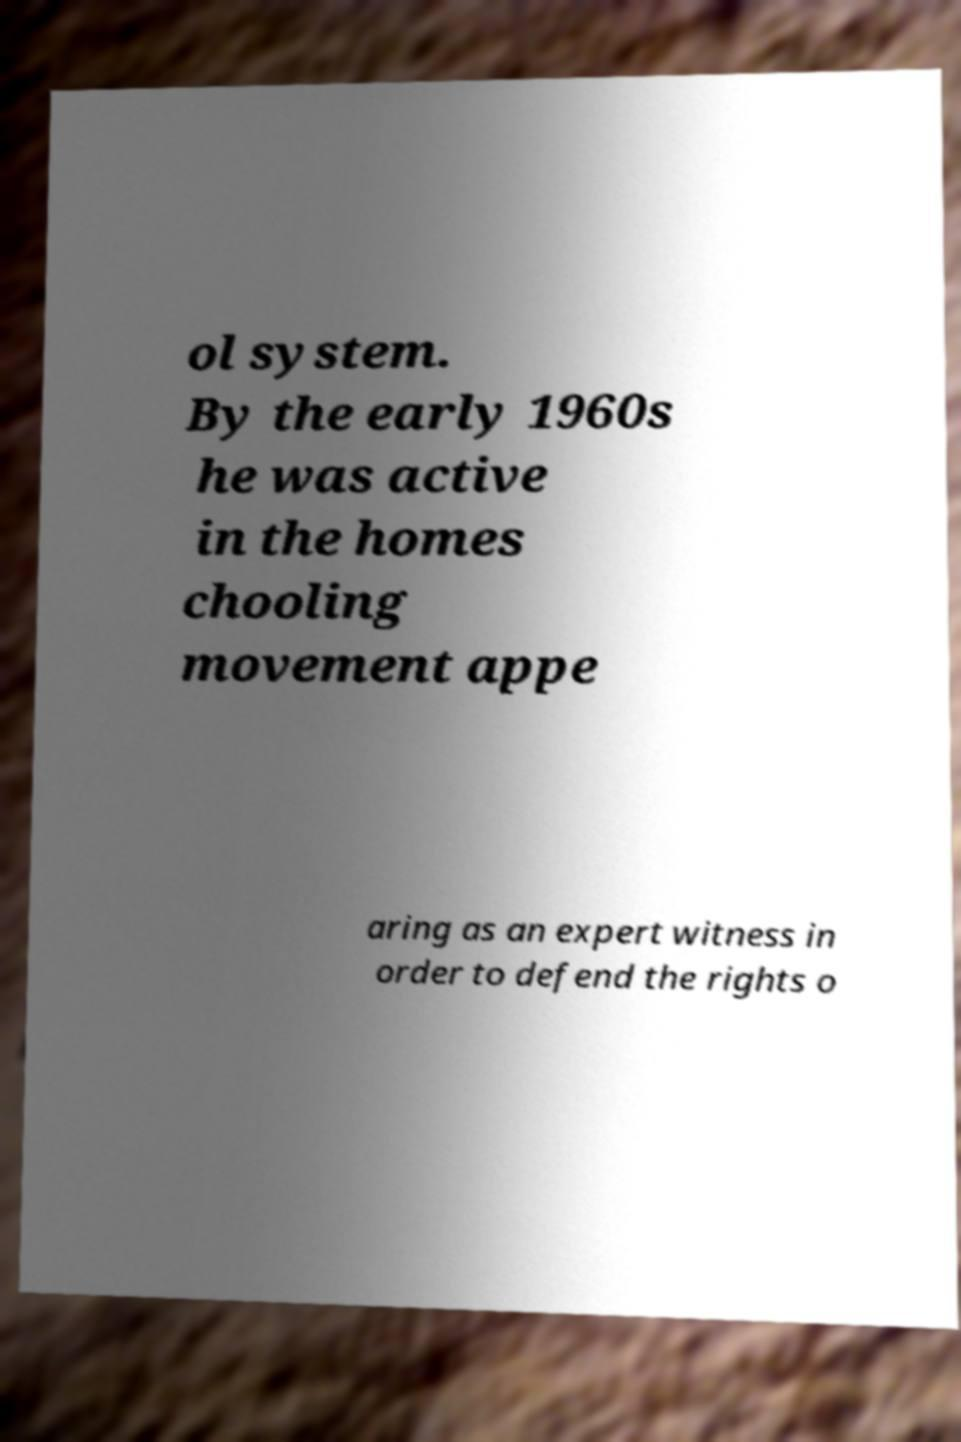Can you read and provide the text displayed in the image?This photo seems to have some interesting text. Can you extract and type it out for me? ol system. By the early 1960s he was active in the homes chooling movement appe aring as an expert witness in order to defend the rights o 